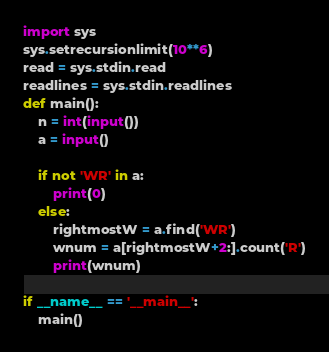Convert code to text. <code><loc_0><loc_0><loc_500><loc_500><_Python_>import sys
sys.setrecursionlimit(10**6)
read = sys.stdin.read
readlines = sys.stdin.readlines
def main():
    n = int(input())
    a = input()

    if not 'WR' in a:
        print(0)
    else:
        rightmostW = a.find('WR')
        wnum = a[rightmostW+2:].count('R')
        print(wnum)

if __name__ == '__main__':
    main()</code> 